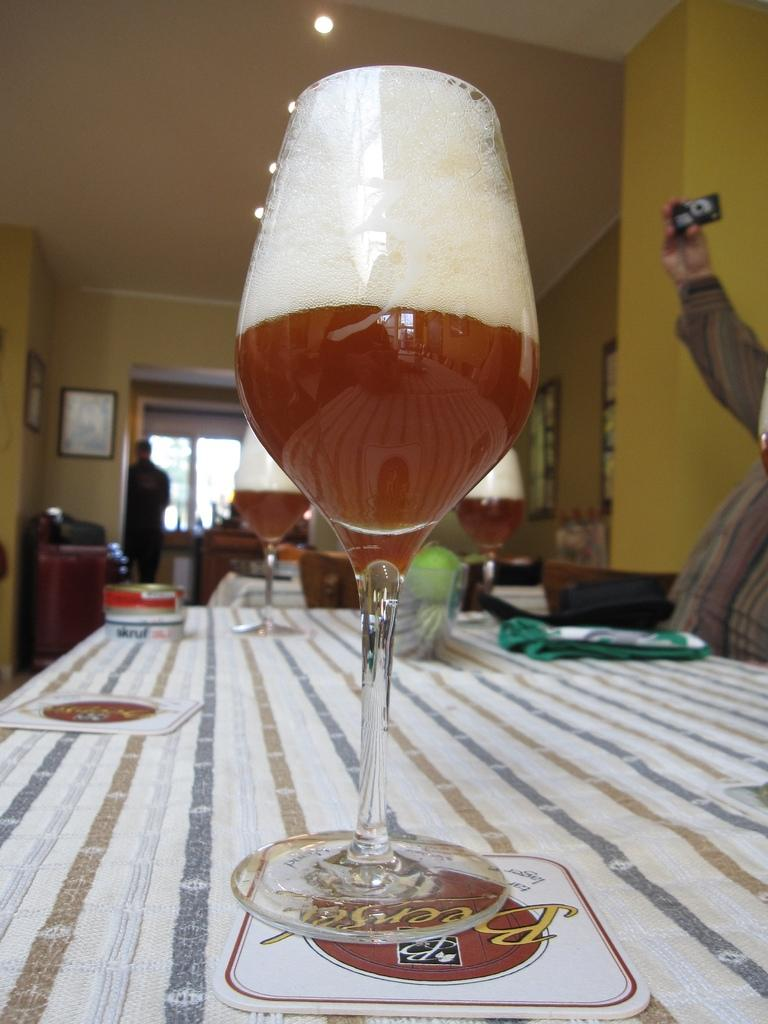What can be seen in the background of the image? There is a window, a table, a person, and photo frames on the wall in the background of the image. What is on the table in the image? There are glasses with drinks on the table in the image. What is the person in the background of the image doing? A person's hand is holding a camera in the image. How many fish are swimming in the glasses with drinks on the table? There are no fish present in the image; the glasses contain drinks. What type of ball is being used by the person holding the camera? There is no ball present in the image; the person is holding a camera. 